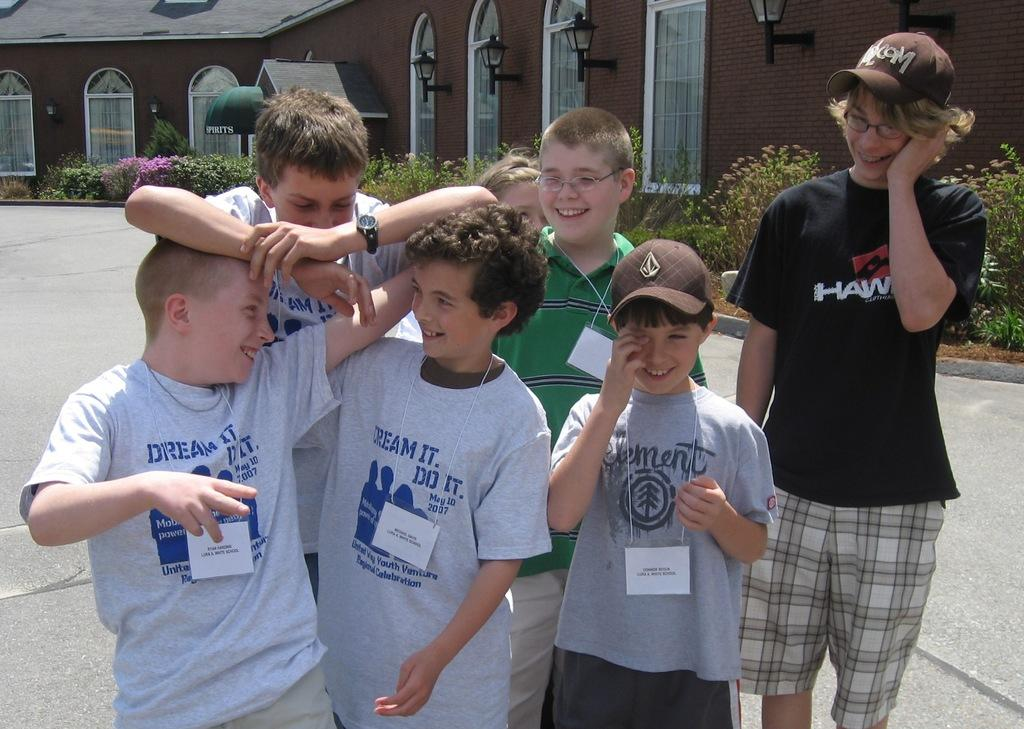What are the main subjects in the center of the image? There are children standing in the center of the image. What can be seen in the background of the image? There is a house in the background of the image. What architectural feature is visible in the image? There are windows visible in the image. What is at the bottom of the image? There is a road at the bottom of the image. What type of rhythm is being played by the children in the image? There is no indication of any rhythm being played in the image; the children are simply standing. 